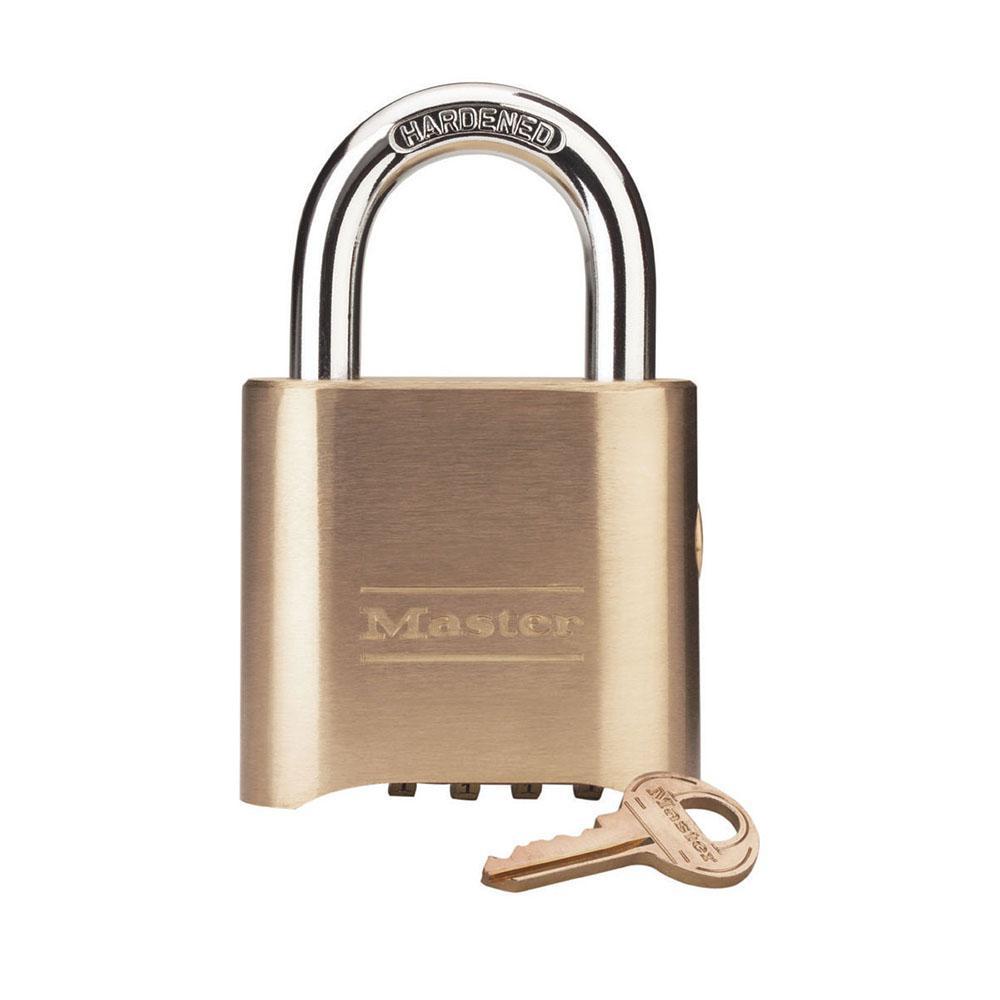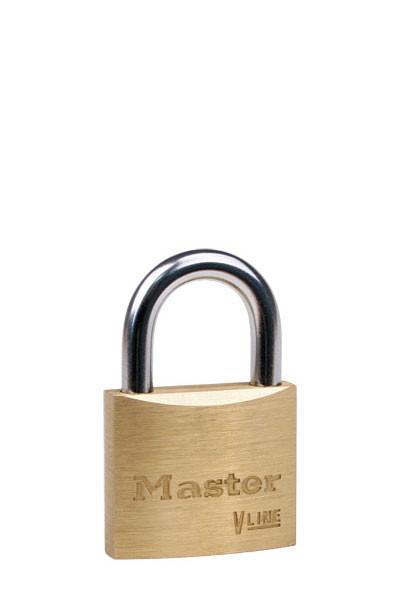The first image is the image on the left, the second image is the image on the right. For the images shown, is this caption "There is only one key." true? Answer yes or no. Yes. The first image is the image on the left, the second image is the image on the right. Assess this claim about the two images: "There are at least 3 keys on keyrings.". Correct or not? Answer yes or no. No. 